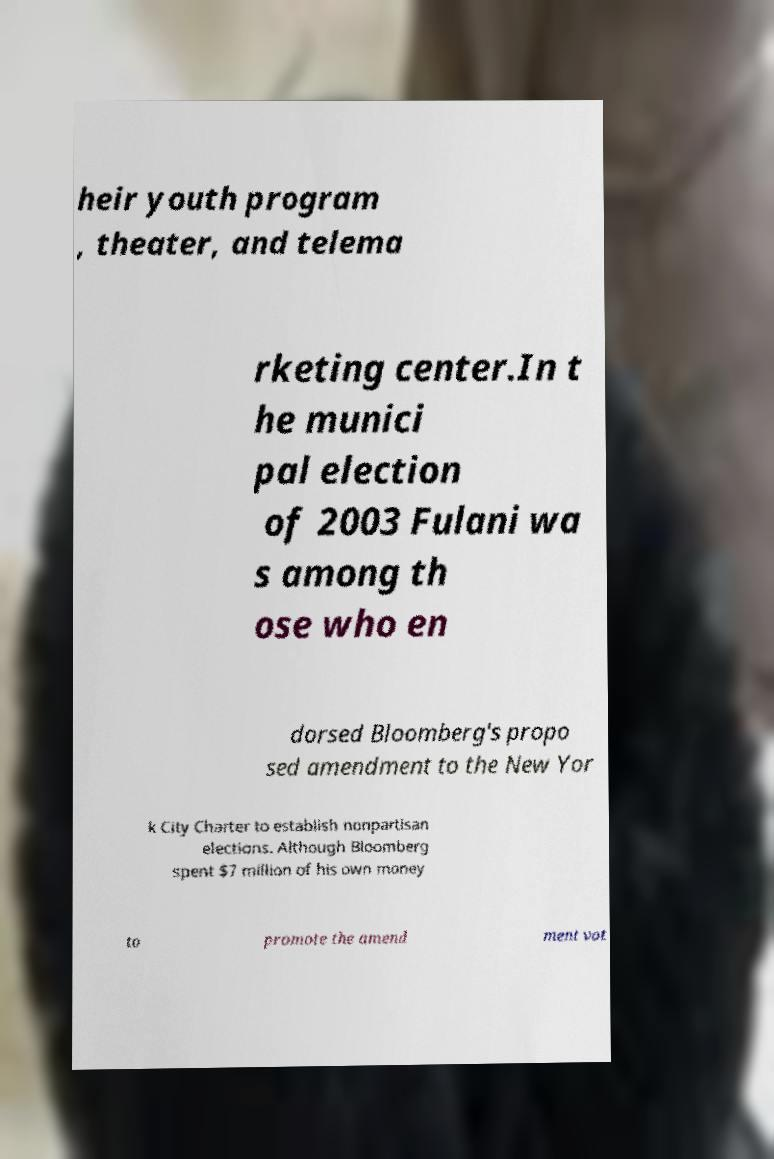I need the written content from this picture converted into text. Can you do that? heir youth program , theater, and telema rketing center.In t he munici pal election of 2003 Fulani wa s among th ose who en dorsed Bloomberg's propo sed amendment to the New Yor k City Charter to establish nonpartisan elections. Although Bloomberg spent $7 million of his own money to promote the amend ment vot 